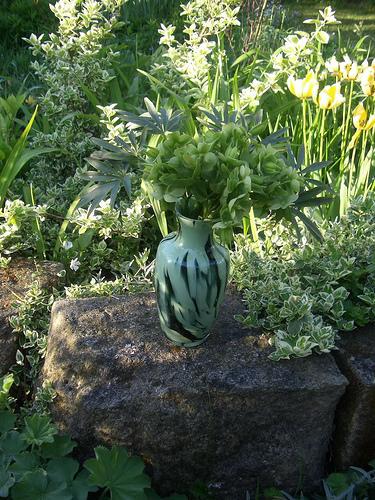What color is the vase?
Quick response, please. Green. What is in the vase?
Give a very brief answer. Flowers. What is the vase sitting on?
Write a very short answer. Rock. 